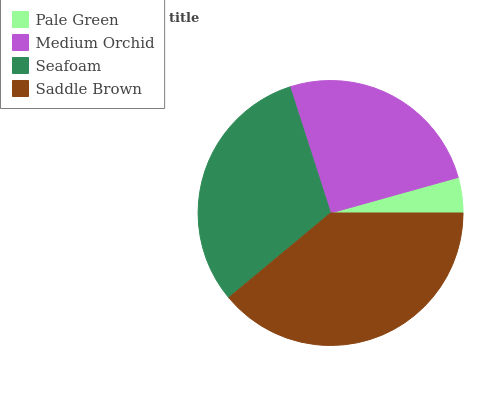Is Pale Green the minimum?
Answer yes or no. Yes. Is Saddle Brown the maximum?
Answer yes or no. Yes. Is Medium Orchid the minimum?
Answer yes or no. No. Is Medium Orchid the maximum?
Answer yes or no. No. Is Medium Orchid greater than Pale Green?
Answer yes or no. Yes. Is Pale Green less than Medium Orchid?
Answer yes or no. Yes. Is Pale Green greater than Medium Orchid?
Answer yes or no. No. Is Medium Orchid less than Pale Green?
Answer yes or no. No. Is Seafoam the high median?
Answer yes or no. Yes. Is Medium Orchid the low median?
Answer yes or no. Yes. Is Pale Green the high median?
Answer yes or no. No. Is Saddle Brown the low median?
Answer yes or no. No. 